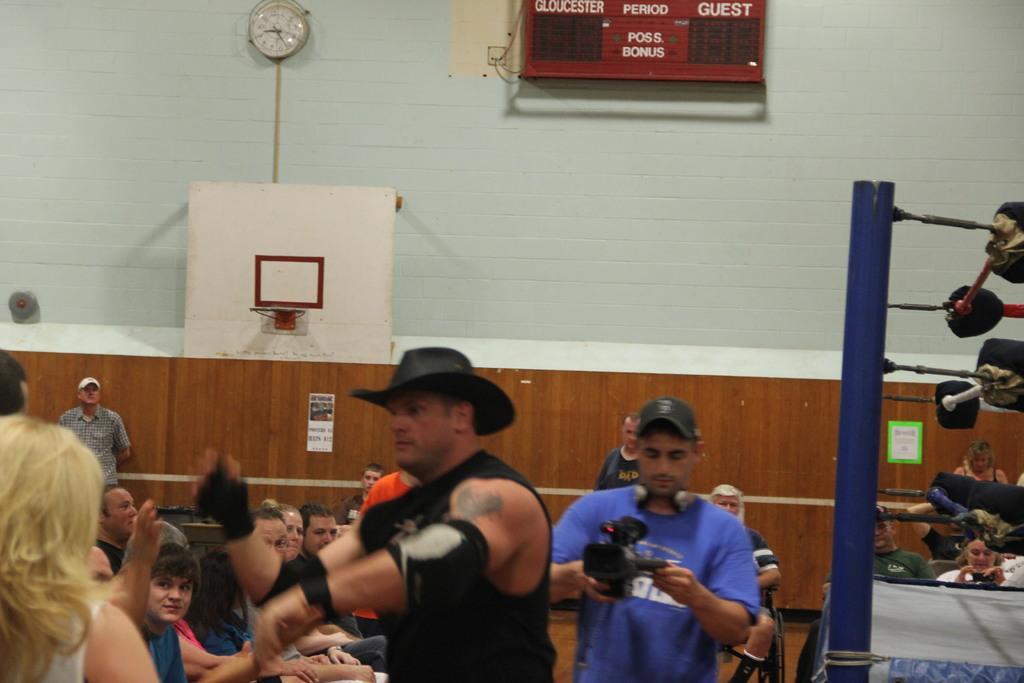Describe this image in one or two sentences. In this image I can see a person wearing black colored dress and black colored hat is standing and another person wearing blue colored t shirt is standing and holding a camera in his hand. In the background I can see few persons standing, the brown colored surface, a clock and a score board. 